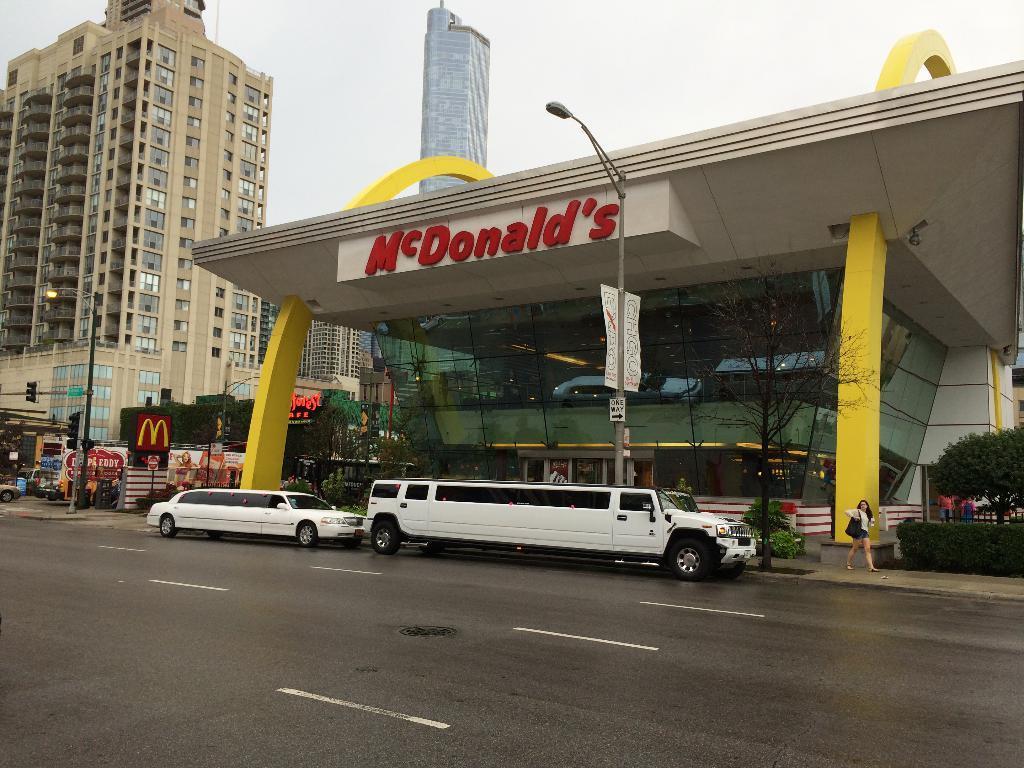Please provide a concise description of this image. In this image we can see some buildings and windows. And we can see the vehicles. And we can see the road. And we can see the street lights, traffic signals and sign boards. And we can see the trees. And we can see some people standing. And we can see the sky. 